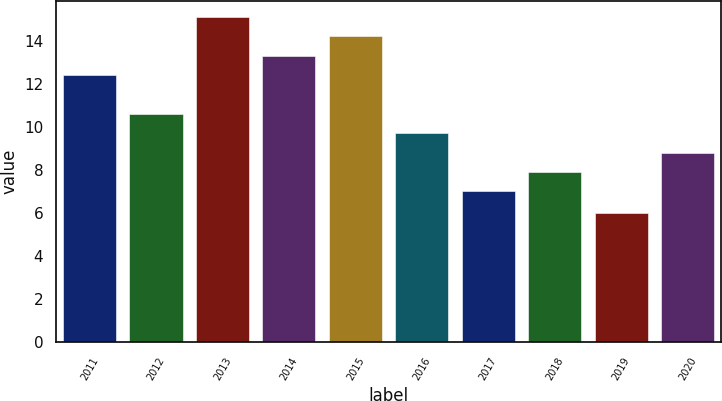<chart> <loc_0><loc_0><loc_500><loc_500><bar_chart><fcel>2011<fcel>2012<fcel>2013<fcel>2014<fcel>2015<fcel>2016<fcel>2017<fcel>2018<fcel>2019<fcel>2020<nl><fcel>12.4<fcel>10.6<fcel>15.1<fcel>13.3<fcel>14.2<fcel>9.7<fcel>7<fcel>7.9<fcel>6<fcel>8.8<nl></chart> 